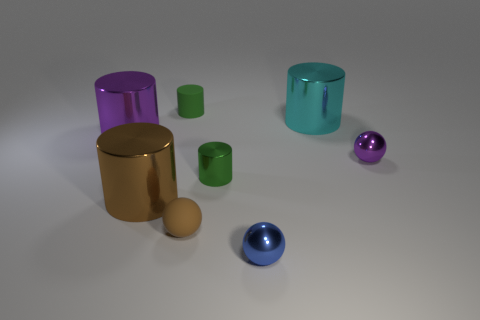Is the number of large gray matte cylinders less than the number of small green cylinders?
Give a very brief answer. Yes. What number of balls are purple things or big metallic objects?
Your answer should be very brief. 1. What number of big shiny objects are the same color as the small rubber sphere?
Offer a very short reply. 1. How big is the metallic object that is behind the green metal object and to the left of the tiny green shiny cylinder?
Offer a terse response. Large. Are there fewer large cylinders on the right side of the small brown sphere than brown rubber balls?
Make the answer very short. No. Is the brown cylinder made of the same material as the brown ball?
Your answer should be compact. No. How many things are either brown cylinders or small purple objects?
Offer a terse response. 2. What number of green objects have the same material as the big purple cylinder?
Offer a very short reply. 1. There is a green shiny object that is the same shape as the large purple object; what size is it?
Your answer should be very brief. Small. Are there any blue metallic things to the left of the big purple object?
Your answer should be very brief. No. 